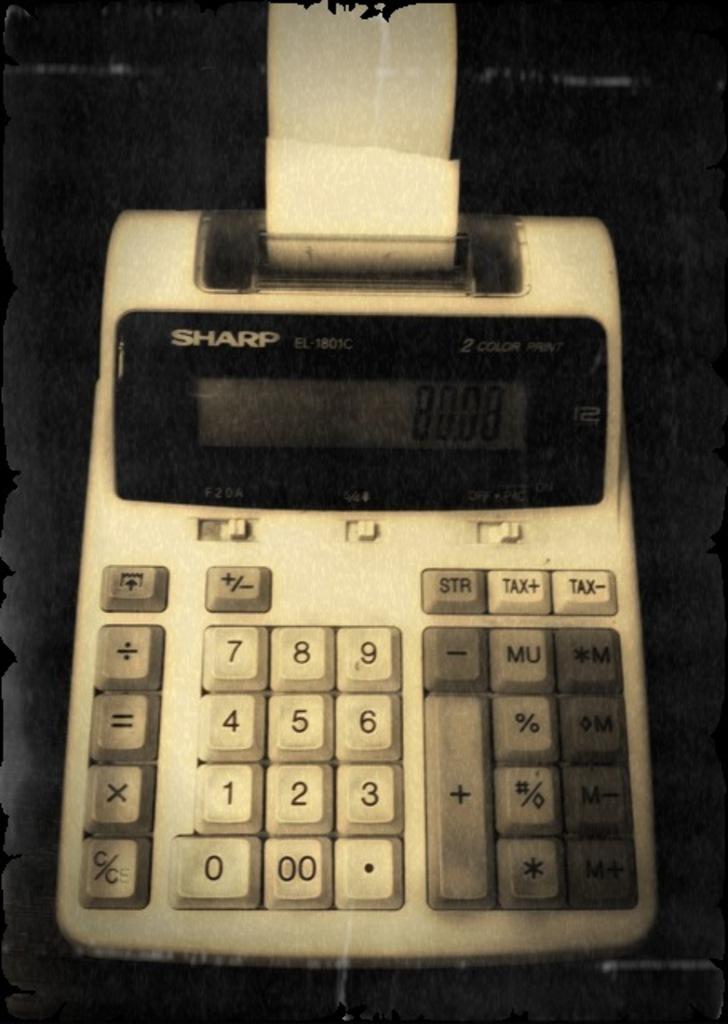Is that a sharp electric machine?
Give a very brief answer. Yes. 